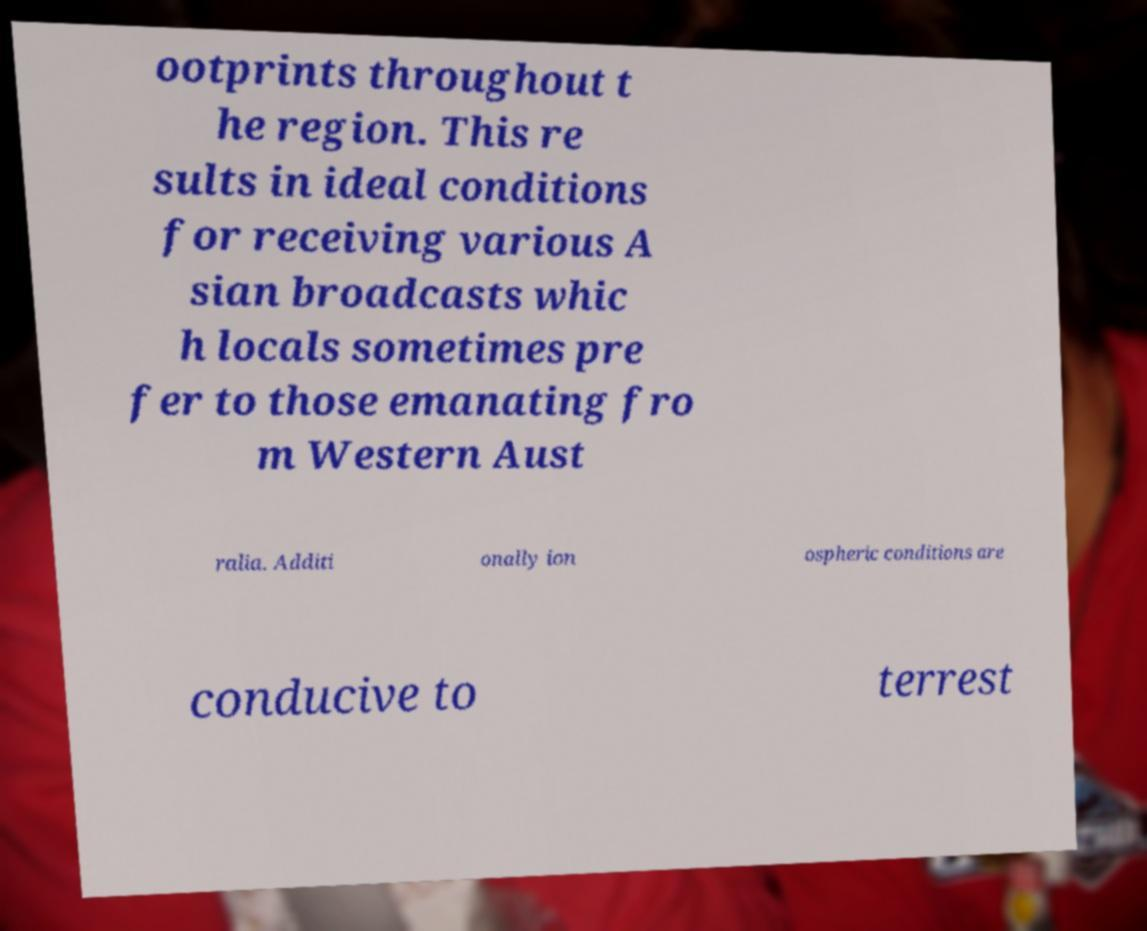Please identify and transcribe the text found in this image. ootprints throughout t he region. This re sults in ideal conditions for receiving various A sian broadcasts whic h locals sometimes pre fer to those emanating fro m Western Aust ralia. Additi onally ion ospheric conditions are conducive to terrest 